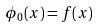<formula> <loc_0><loc_0><loc_500><loc_500>\phi _ { 0 } ( x ) = f ( x )</formula> 